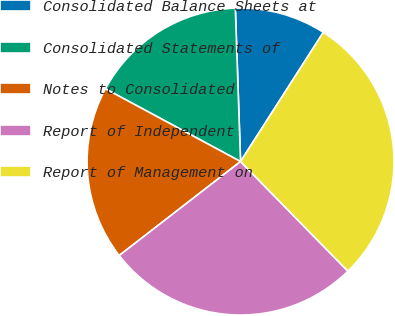Convert chart to OTSL. <chart><loc_0><loc_0><loc_500><loc_500><pie_chart><fcel>Consolidated Balance Sheets at<fcel>Consolidated Statements of<fcel>Notes to Consolidated<fcel>Report of Independent<fcel>Report of Management on<nl><fcel>9.61%<fcel>16.6%<fcel>18.35%<fcel>26.85%<fcel>28.6%<nl></chart> 